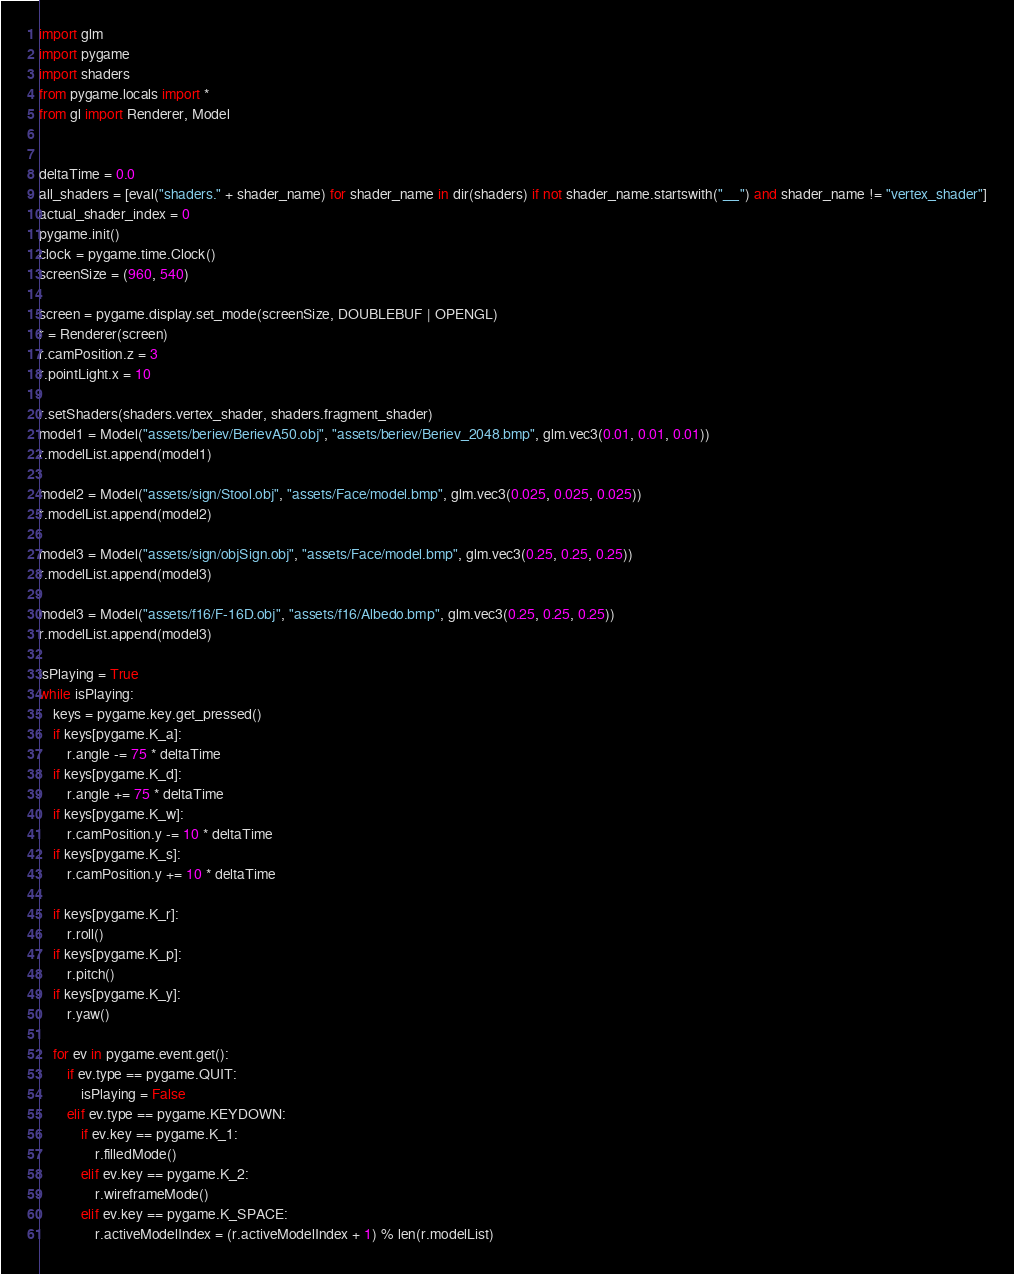<code> <loc_0><loc_0><loc_500><loc_500><_Python_>import glm
import pygame
import shaders
from pygame.locals import *
from gl import Renderer, Model


deltaTime = 0.0
all_shaders = [eval("shaders." + shader_name) for shader_name in dir(shaders) if not shader_name.startswith("__") and shader_name != "vertex_shader"]
actual_shader_index = 0
pygame.init()
clock = pygame.time.Clock()
screenSize = (960, 540)

screen = pygame.display.set_mode(screenSize, DOUBLEBUF | OPENGL)
r = Renderer(screen)
r.camPosition.z = 3
r.pointLight.x = 10

r.setShaders(shaders.vertex_shader, shaders.fragment_shader)
model1 = Model("assets/beriev/BerievA50.obj", "assets/beriev/Beriev_2048.bmp", glm.vec3(0.01, 0.01, 0.01))
r.modelList.append(model1)

model2 = Model("assets/sign/Stool.obj", "assets/Face/model.bmp", glm.vec3(0.025, 0.025, 0.025))
r.modelList.append(model2)

model3 = Model("assets/sign/objSign.obj", "assets/Face/model.bmp", glm.vec3(0.25, 0.25, 0.25))
r.modelList.append(model3)

model3 = Model("assets/f16/F-16D.obj", "assets/f16/Albedo.bmp", glm.vec3(0.25, 0.25, 0.25))
r.modelList.append(model3)

isPlaying = True
while isPlaying:
    keys = pygame.key.get_pressed()
    if keys[pygame.K_a]:
        r.angle -= 75 * deltaTime
    if keys[pygame.K_d]:
        r.angle += 75 * deltaTime
    if keys[pygame.K_w]:
        r.camPosition.y -= 10 * deltaTime
    if keys[pygame.K_s]:
        r.camPosition.y += 10 * deltaTime

    if keys[pygame.K_r]:
        r.roll()
    if keys[pygame.K_p]:
        r.pitch()
    if keys[pygame.K_y]:
        r.yaw()

    for ev in pygame.event.get():
        if ev.type == pygame.QUIT:
            isPlaying = False
        elif ev.type == pygame.KEYDOWN:
            if ev.key == pygame.K_1:
                r.filledMode()
            elif ev.key == pygame.K_2:
                r.wireframeMode()
            elif ev.key == pygame.K_SPACE:
                r.activeModelIndex = (r.activeModelIndex + 1) % len(r.modelList)</code> 